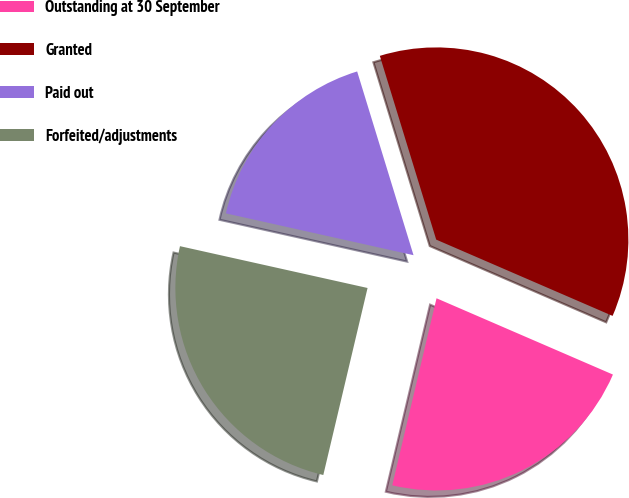<chart> <loc_0><loc_0><loc_500><loc_500><pie_chart><fcel>Outstanding at 30 September<fcel>Granted<fcel>Paid out<fcel>Forfeited/adjustments<nl><fcel>22.2%<fcel>36.23%<fcel>16.77%<fcel>24.79%<nl></chart> 